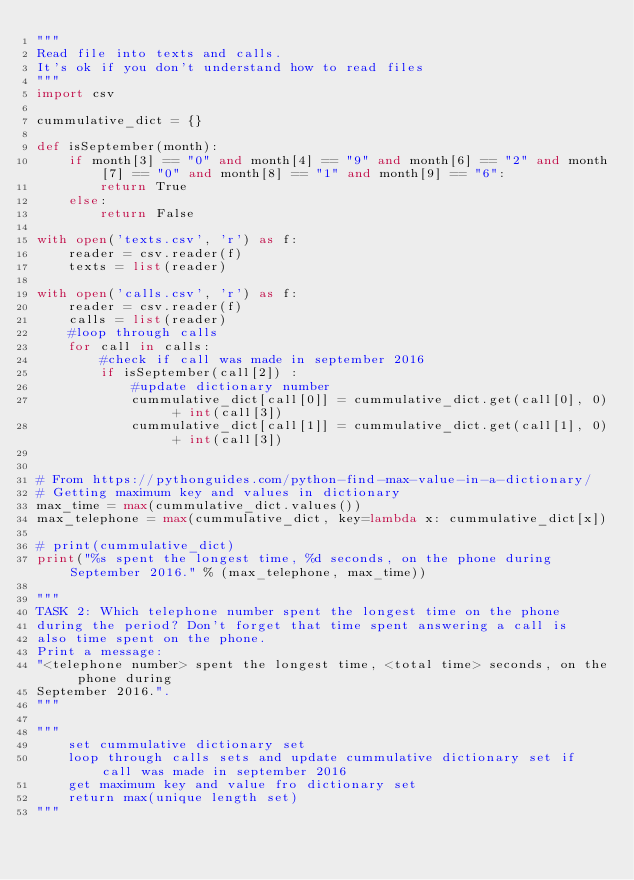<code> <loc_0><loc_0><loc_500><loc_500><_Python_>"""
Read file into texts and calls.
It's ok if you don't understand how to read files
"""
import csv

cummulative_dict = {}

def isSeptember(month):
    if month[3] == "0" and month[4] == "9" and month[6] == "2" and month[7] == "0" and month[8] == "1" and month[9] == "6":
        return True
    else:
        return False

with open('texts.csv', 'r') as f:
    reader = csv.reader(f)
    texts = list(reader)

with open('calls.csv', 'r') as f:
    reader = csv.reader(f)
    calls = list(reader)
    #loop through calls
    for call in calls:
        #check if call was made in september 2016
        if isSeptember(call[2]) :
            #update dictionary number 
            cummulative_dict[call[0]] = cummulative_dict.get(call[0], 0) + int(call[3])
            cummulative_dict[call[1]] = cummulative_dict.get(call[1], 0) + int(call[3])


# From https://pythonguides.com/python-find-max-value-in-a-dictionary/
# Getting maximum key and values in dictionary
max_time = max(cummulative_dict.values())
max_telephone = max(cummulative_dict, key=lambda x: cummulative_dict[x])

# print(cummulative_dict)
print("%s spent the longest time, %d seconds, on the phone during September 2016." % (max_telephone, max_time))

"""
TASK 2: Which telephone number spent the longest time on the phone
during the period? Don't forget that time spent answering a call is
also time spent on the phone.
Print a message:
"<telephone number> spent the longest time, <total time> seconds, on the phone during 
September 2016.".
"""

"""
    set cummulative dictionary set
    loop through calls sets and update cummulative dictionary set if call was made in september 2016
    get maximum key and value fro dictionary set
    return max(unique length set)
"""
</code> 